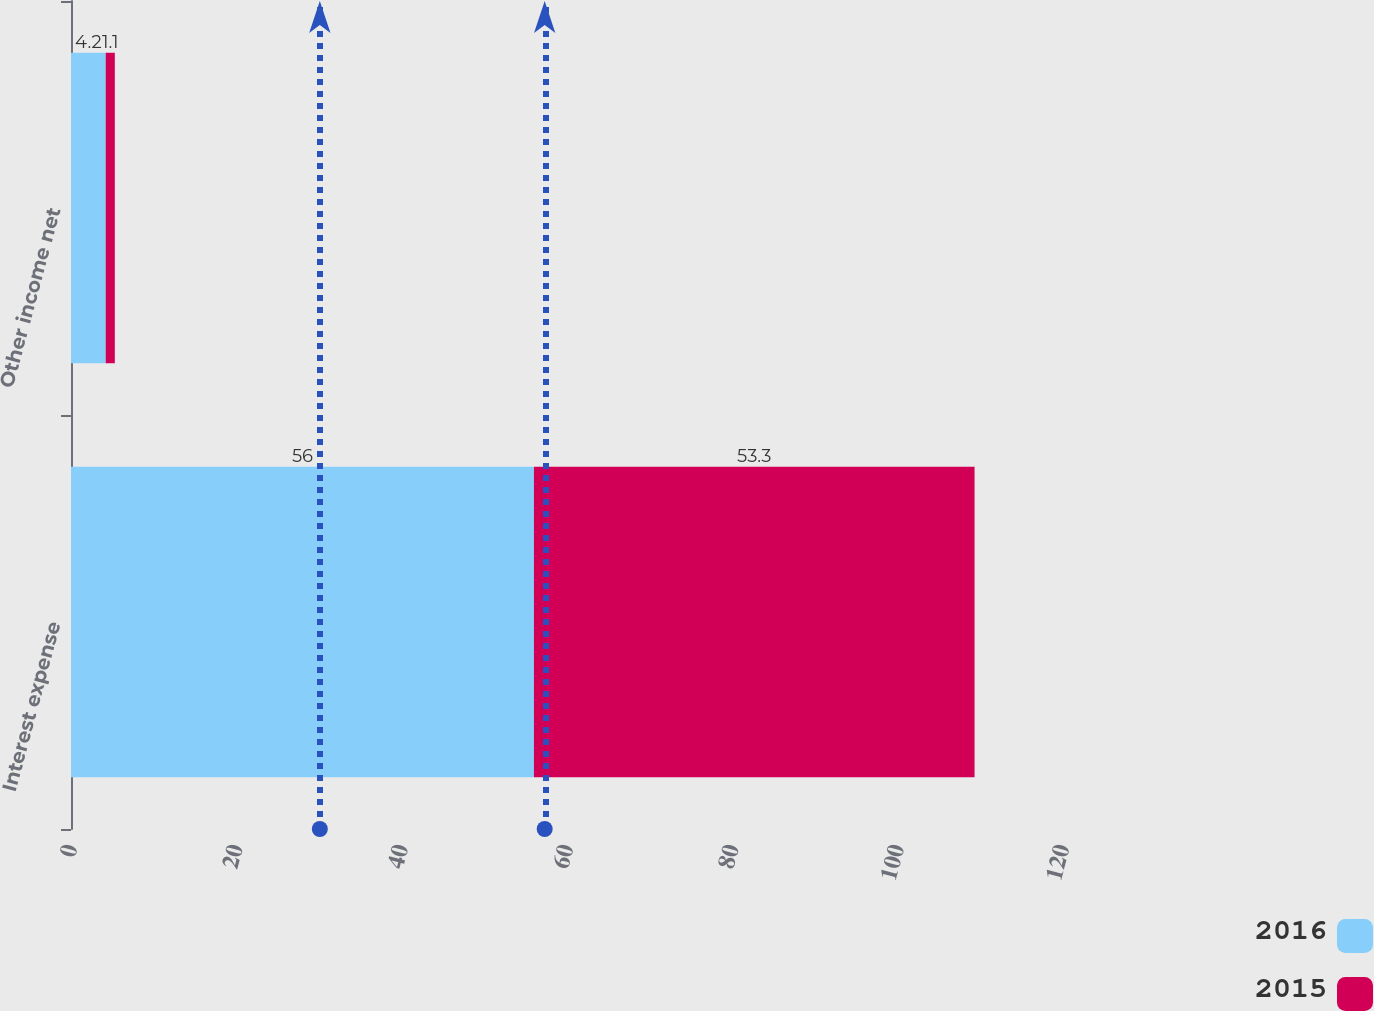<chart> <loc_0><loc_0><loc_500><loc_500><stacked_bar_chart><ecel><fcel>Interest expense<fcel>Other income net<nl><fcel>2016<fcel>56<fcel>4.2<nl><fcel>2015<fcel>53.3<fcel>1.1<nl></chart> 